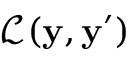<formula> <loc_0><loc_0><loc_500><loc_500>\mathcal { L } ( y , y ^ { \prime } )</formula> 